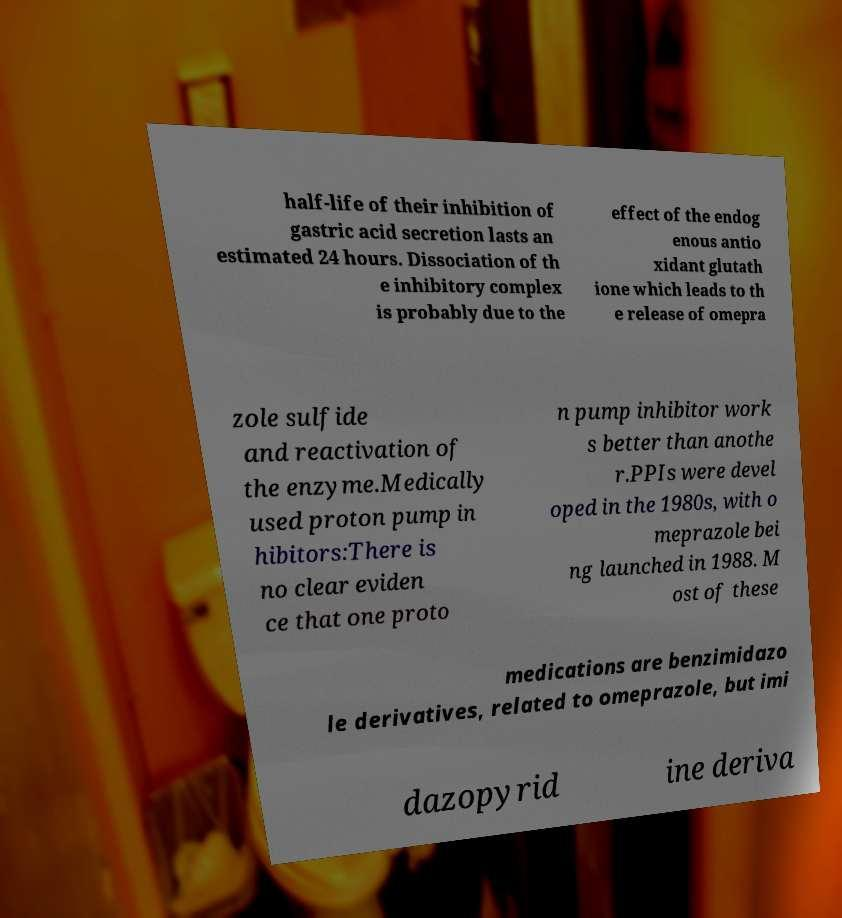Can you accurately transcribe the text from the provided image for me? half-life of their inhibition of gastric acid secretion lasts an estimated 24 hours. Dissociation of th e inhibitory complex is probably due to the effect of the endog enous antio xidant glutath ione which leads to th e release of omepra zole sulfide and reactivation of the enzyme.Medically used proton pump in hibitors:There is no clear eviden ce that one proto n pump inhibitor work s better than anothe r.PPIs were devel oped in the 1980s, with o meprazole bei ng launched in 1988. M ost of these medications are benzimidazo le derivatives, related to omeprazole, but imi dazopyrid ine deriva 